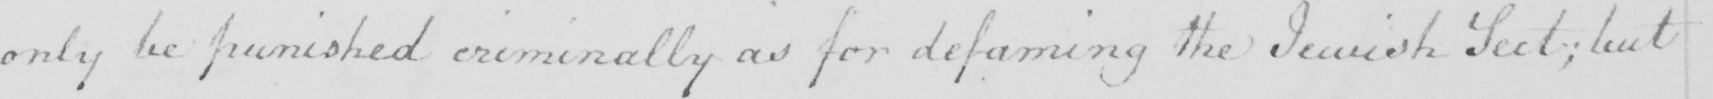What is written in this line of handwriting? only be punished criminally as for defaming the Jewish Sect ; but 